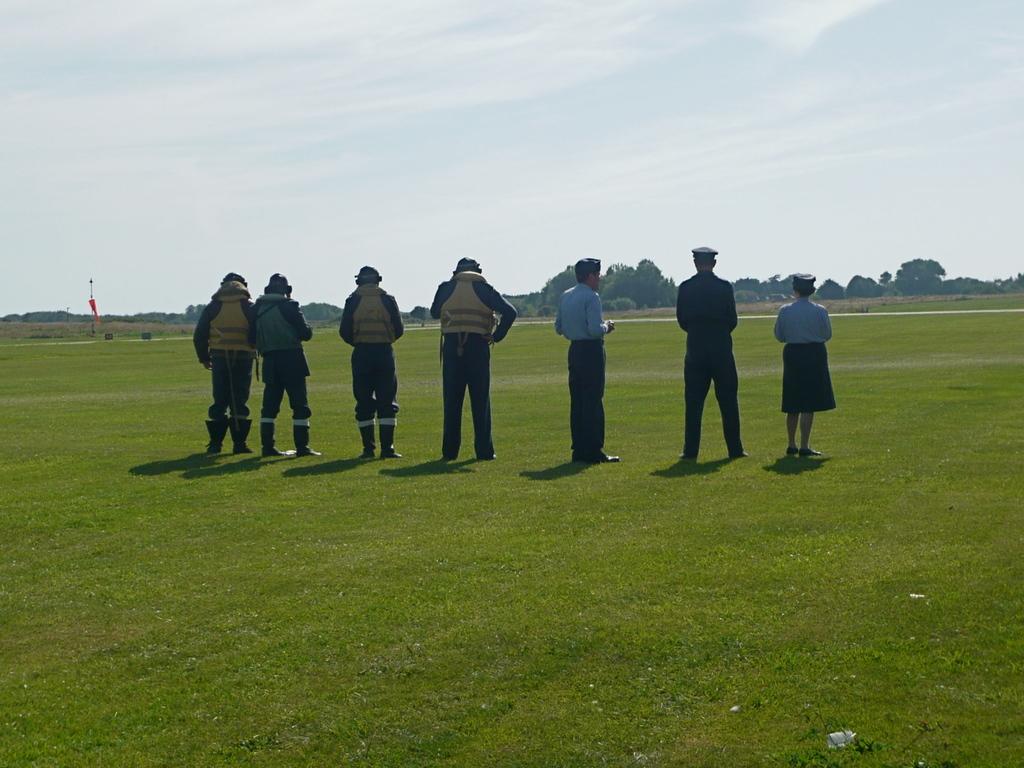Please provide a concise description of this image. In this image we can see persons standing on the ground. In the background we can see pole, flag, trees and sky with clouds. 